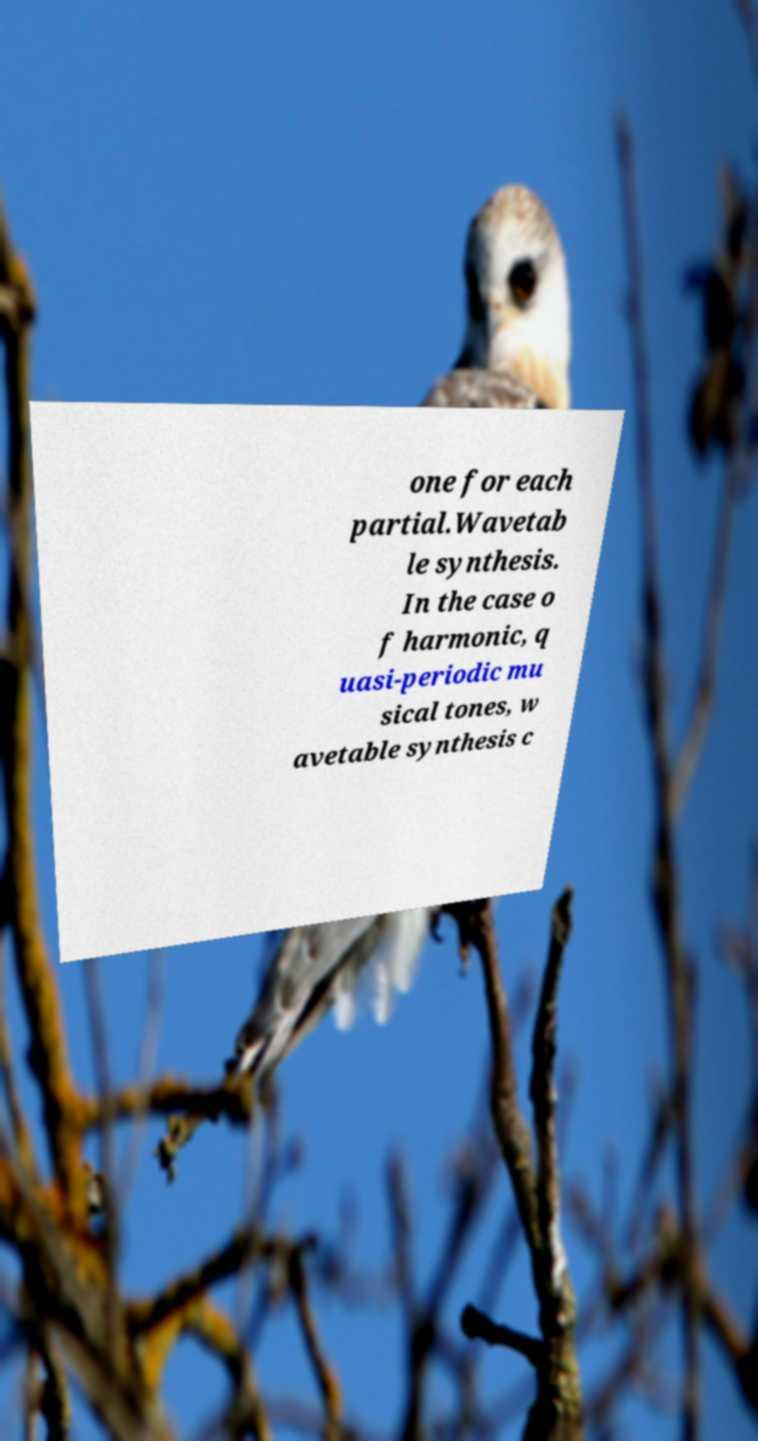What messages or text are displayed in this image? I need them in a readable, typed format. one for each partial.Wavetab le synthesis. In the case o f harmonic, q uasi-periodic mu sical tones, w avetable synthesis c 